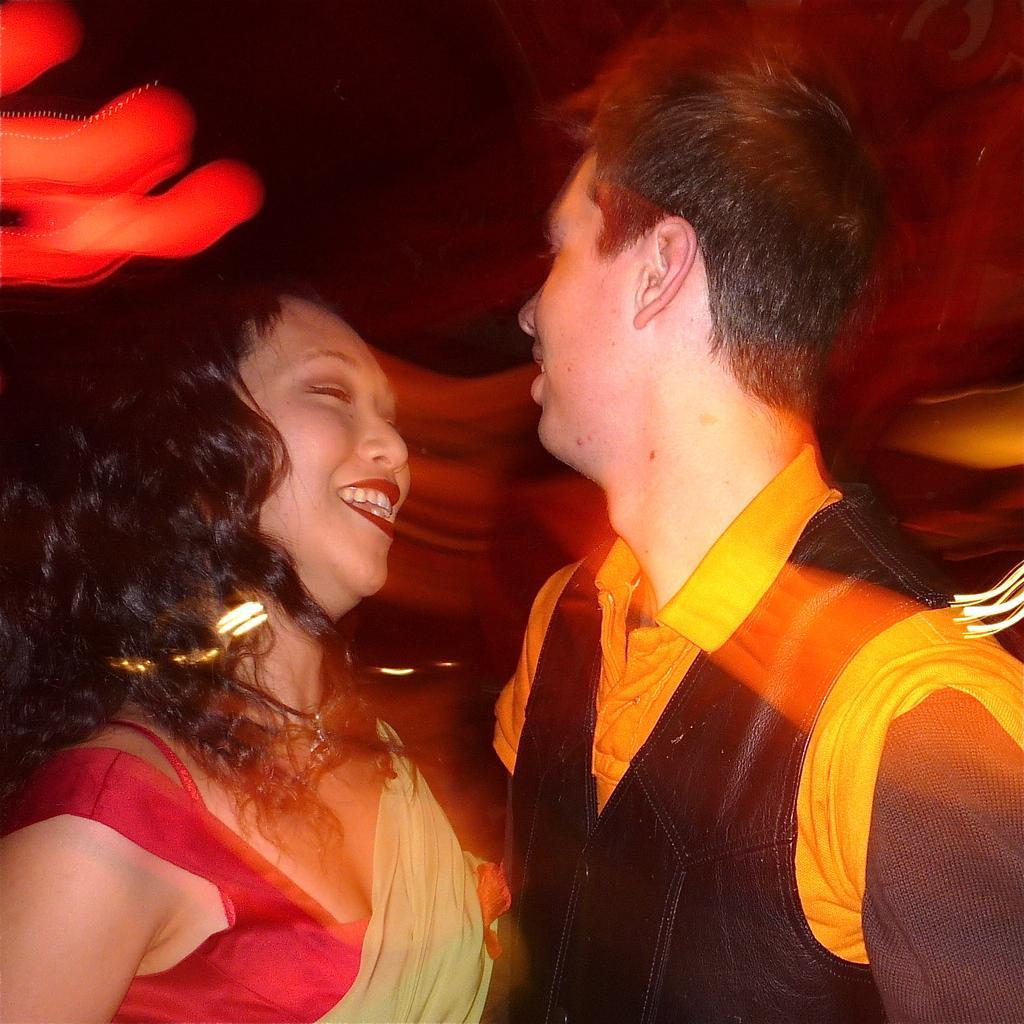Describe this image in one or two sentences. In this image we can see a man and a woman. 